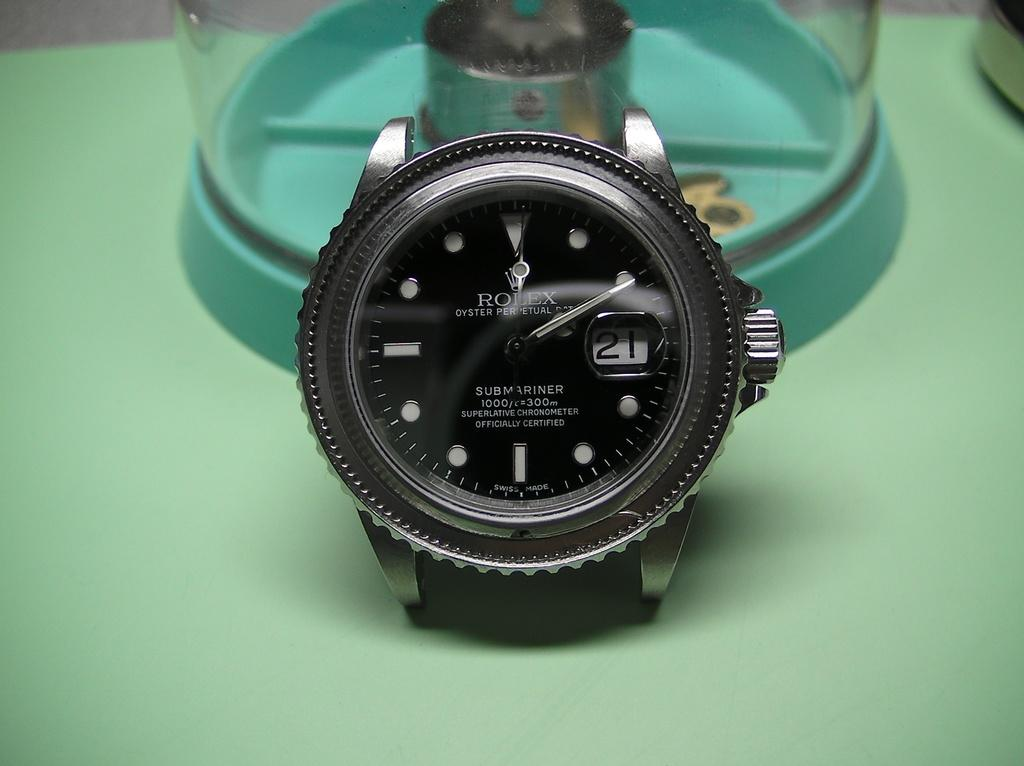<image>
Render a clear and concise summary of the photo. front face view of a Rolex Submariner watch branded "A superlative chronometer" 